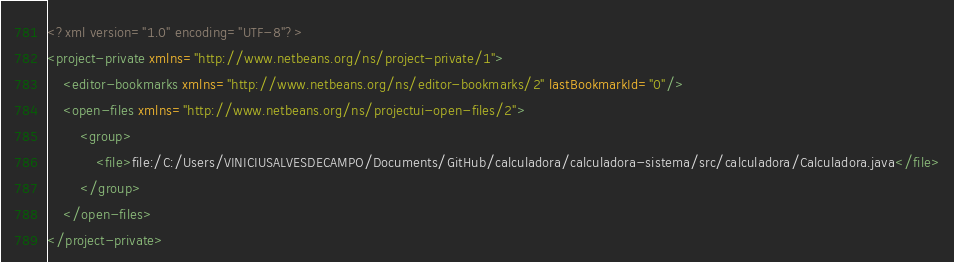<code> <loc_0><loc_0><loc_500><loc_500><_XML_><?xml version="1.0" encoding="UTF-8"?>
<project-private xmlns="http://www.netbeans.org/ns/project-private/1">
    <editor-bookmarks xmlns="http://www.netbeans.org/ns/editor-bookmarks/2" lastBookmarkId="0"/>
    <open-files xmlns="http://www.netbeans.org/ns/projectui-open-files/2">
        <group>
            <file>file:/C:/Users/VINICIUSALVESDECAMPO/Documents/GitHub/calculadora/calculadora-sistema/src/calculadora/Calculadora.java</file>
        </group>
    </open-files>
</project-private>
</code> 